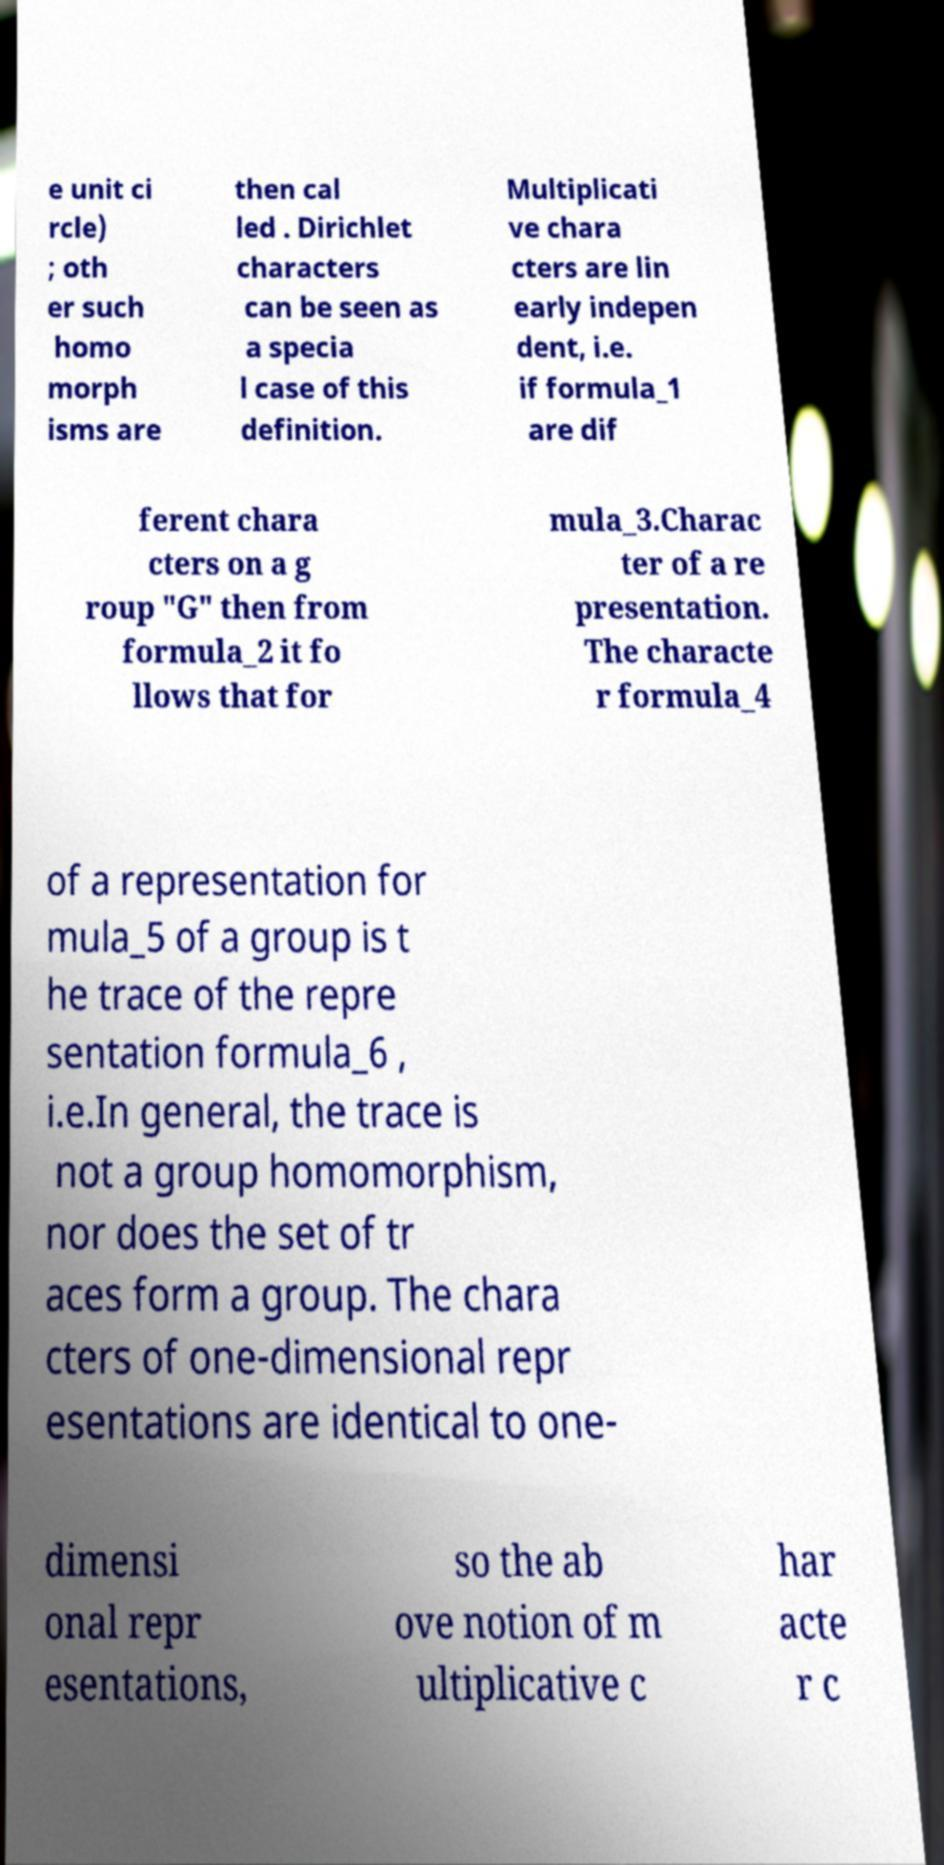I need the written content from this picture converted into text. Can you do that? e unit ci rcle) ; oth er such homo morph isms are then cal led . Dirichlet characters can be seen as a specia l case of this definition. Multiplicati ve chara cters are lin early indepen dent, i.e. if formula_1 are dif ferent chara cters on a g roup "G" then from formula_2 it fo llows that for mula_3.Charac ter of a re presentation. The characte r formula_4 of a representation for mula_5 of a group is t he trace of the repre sentation formula_6 , i.e.In general, the trace is not a group homomorphism, nor does the set of tr aces form a group. The chara cters of one-dimensional repr esentations are identical to one- dimensi onal repr esentations, so the ab ove notion of m ultiplicative c har acte r c 